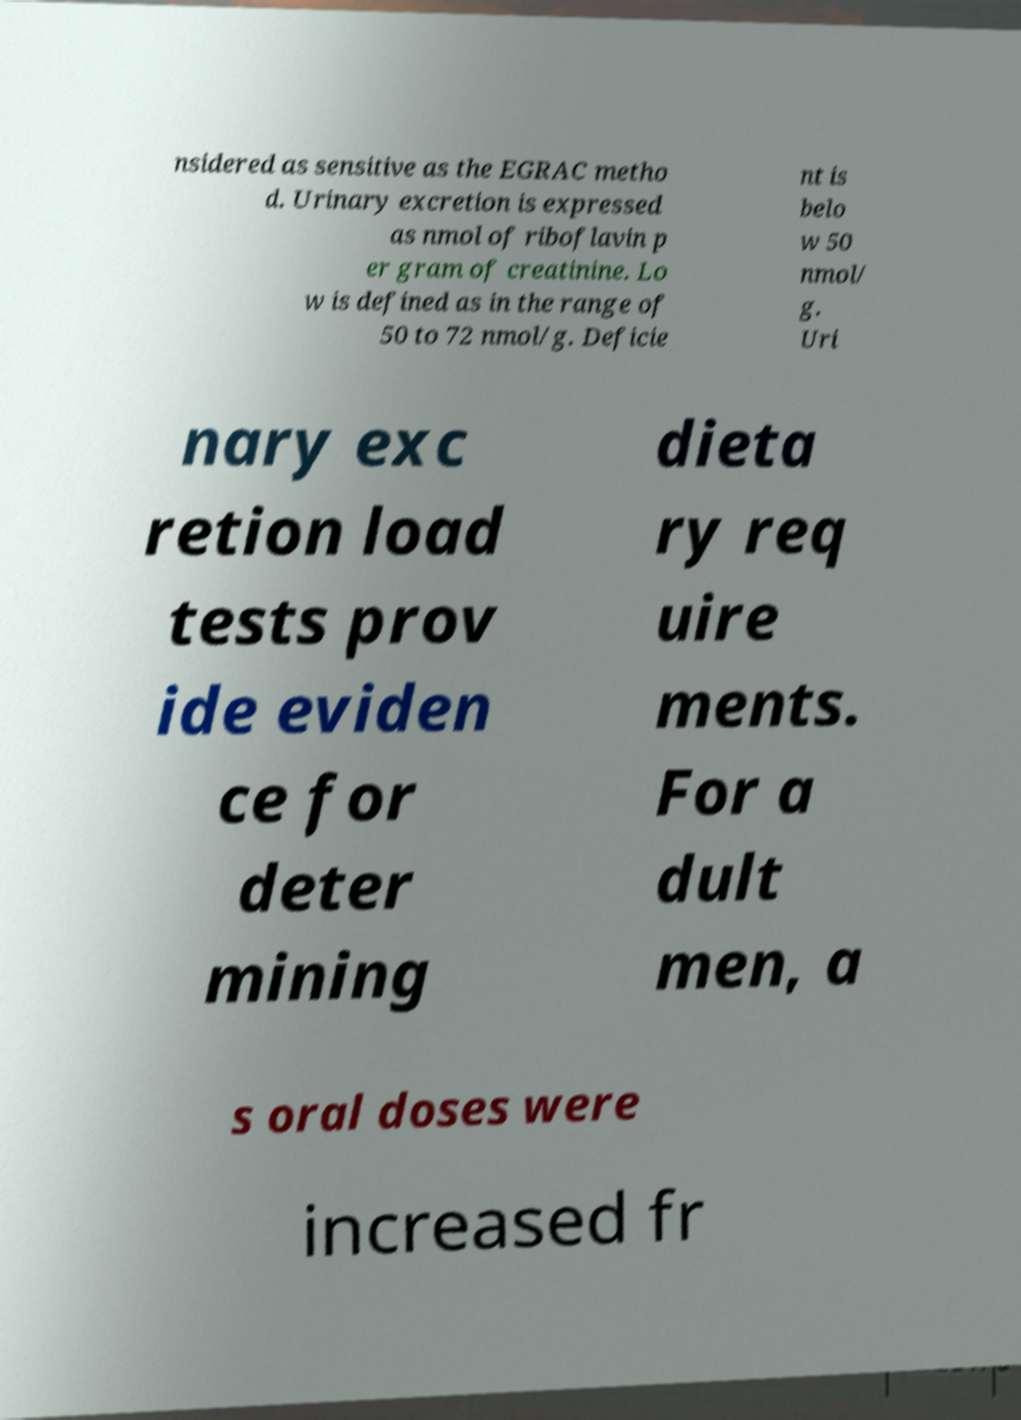I need the written content from this picture converted into text. Can you do that? nsidered as sensitive as the EGRAC metho d. Urinary excretion is expressed as nmol of riboflavin p er gram of creatinine. Lo w is defined as in the range of 50 to 72 nmol/g. Deficie nt is belo w 50 nmol/ g. Uri nary exc retion load tests prov ide eviden ce for deter mining dieta ry req uire ments. For a dult men, a s oral doses were increased fr 